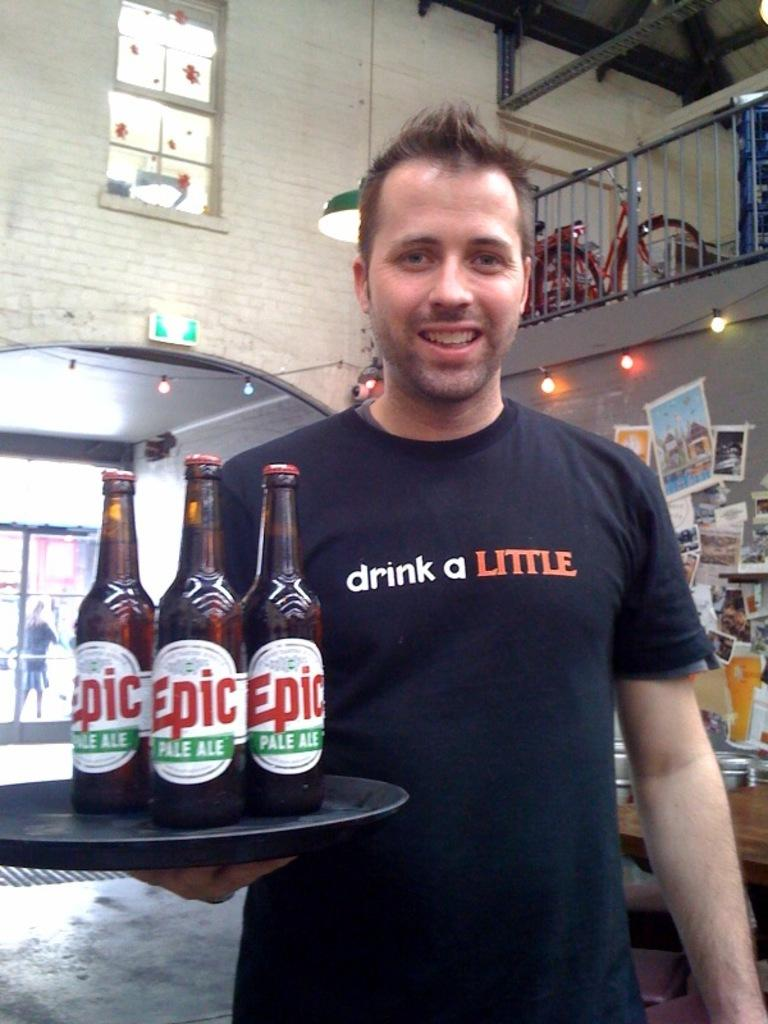Provide a one-sentence caption for the provided image. A man carries bottles of Epic beer on a tray. 